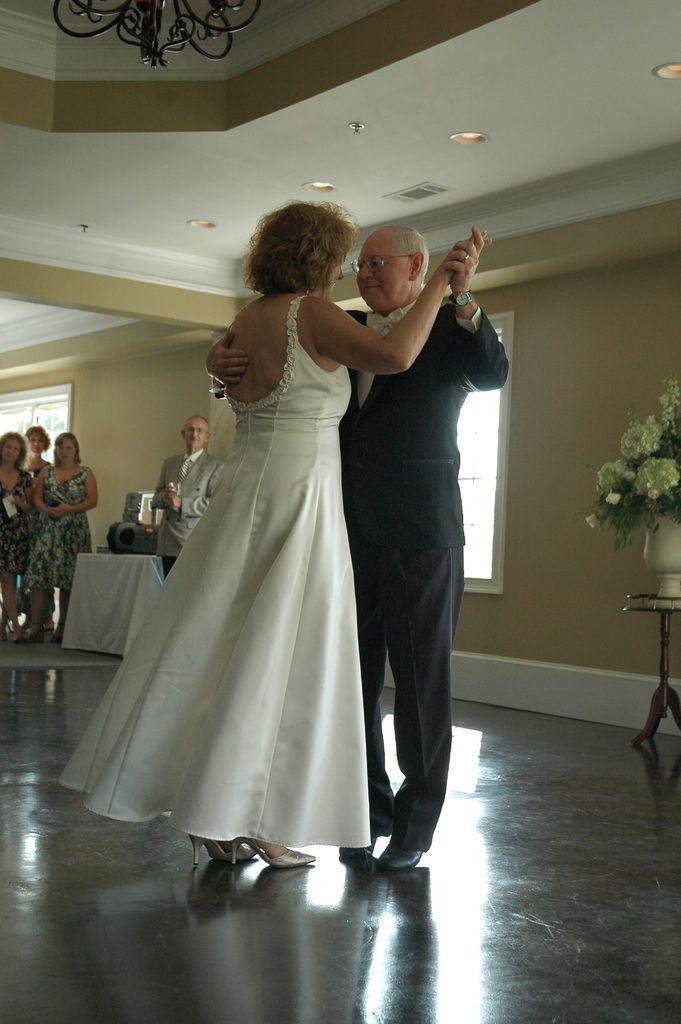In one or two sentences, can you explain what this image depicts? In the center of the image there are people dancing. In the background of the image there is a wall. There are people. There is a window. 